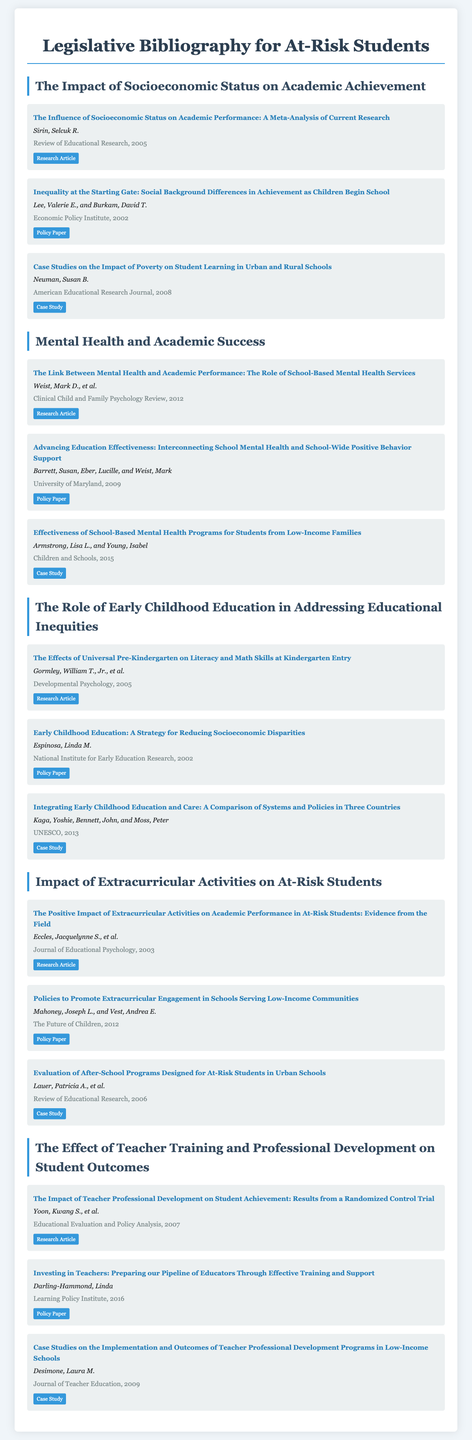What is the title of the first research article listed? The title of the first research article is explicitly mentioned in the document under "The Impact of Socioeconomic Status on Academic Achievement."
Answer: The Influence of Socioeconomic Status on Academic Performance: A Meta-Analysis of Current Research Who is the author of the policy paper on early childhood education? The document identifies the author in the citation of the policy paper related to early childhood education under "The Role of Early Childhood Education in Addressing Educational Inequities."
Answer: Linda M. Espinosa How many case studies are included in the bibliography for "Impact of Extracurricular Activities on At-Risk Students"? To find this, one needs to count the items classified as "Case Study" in that section of the bibliography.
Answer: 1 What year was the case study on the impact of poverty on student learning published? The document provides the publication date next to the title of the case study on poverty's impact on student learning.
Answer: 2008 Which research article discusses the positive effects of extracurricular activities? This question aims to identify the article focusing on extracurricular activities in the relevant section of the bibliography.
Answer: The Positive Impact of Extracurricular Activities on Academic Performance in At-Risk Students: Evidence from the Field What type of document is "Investing in Teachers: Preparing our Pipeline of Educators Through Effective Training and Support"? The type of the document is indicated in the bibliography under the relevant title.
Answer: Policy Paper 